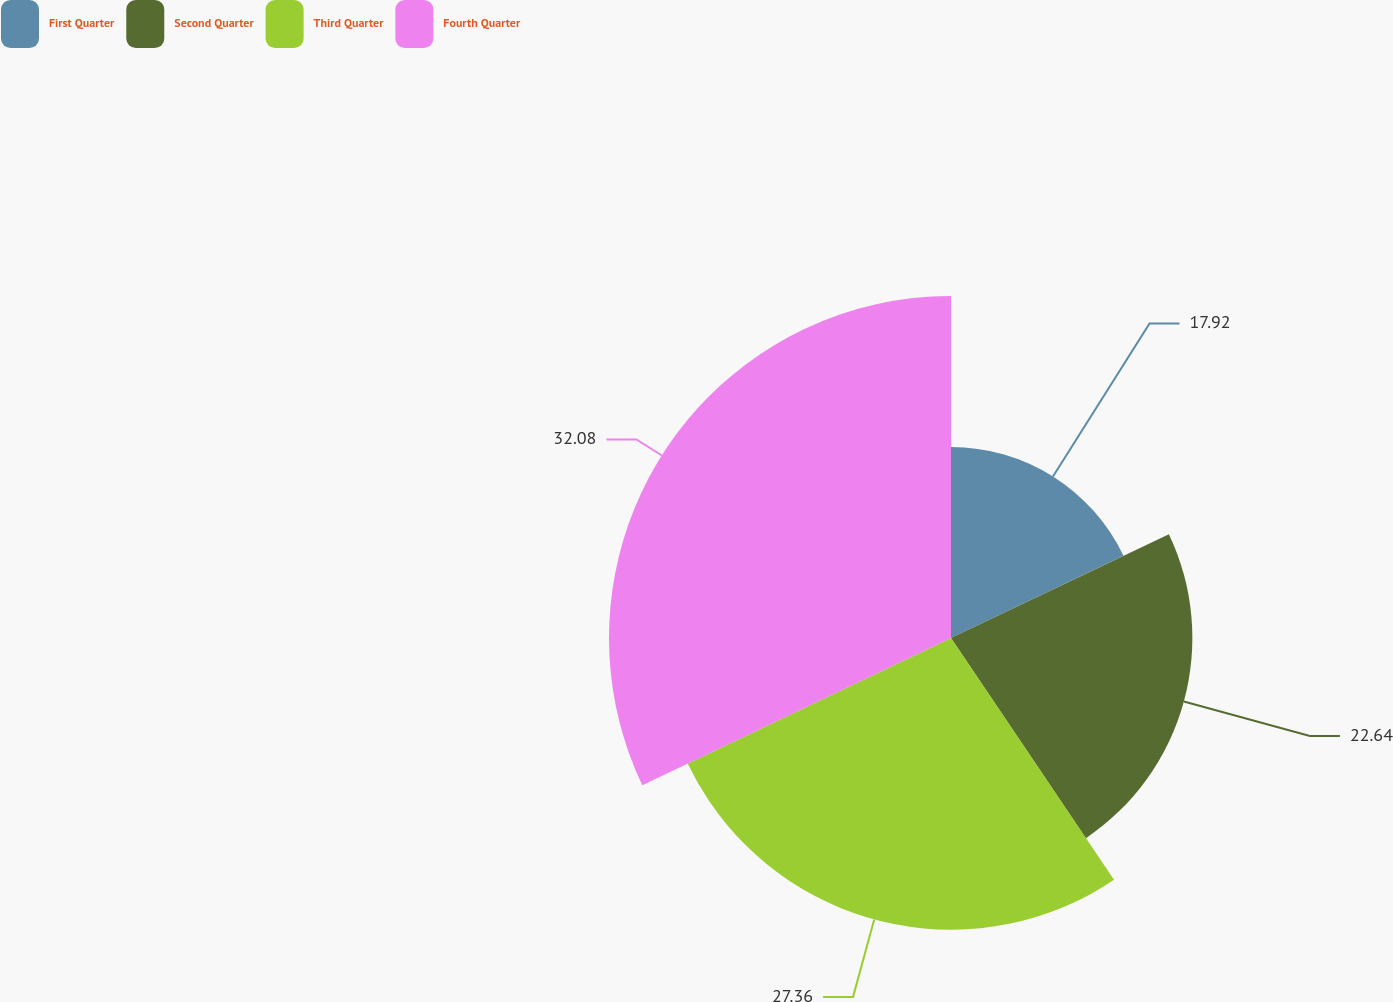Convert chart to OTSL. <chart><loc_0><loc_0><loc_500><loc_500><pie_chart><fcel>First Quarter<fcel>Second Quarter<fcel>Third Quarter<fcel>Fourth Quarter<nl><fcel>17.92%<fcel>22.64%<fcel>27.36%<fcel>32.08%<nl></chart> 